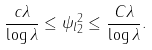Convert formula to latex. <formula><loc_0><loc_0><loc_500><loc_500>\frac { c \lambda } { \log \lambda } \leq \| \psi _ { l } \| _ { 2 } ^ { 2 } \leq \frac { C \lambda } { \log \lambda } .</formula> 